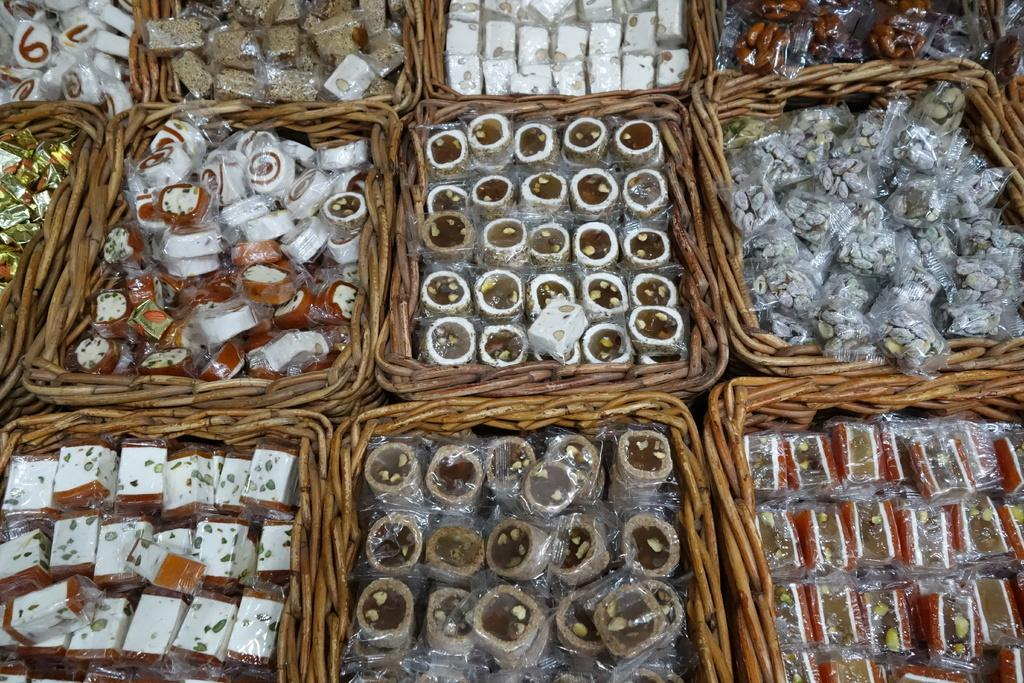What type of items can be seen in the image? There are sweets in the image. How are the sweets arranged or organized? The sweets are placed in baskets. What type of apparel is being worn by the children in the image? There are no children or apparel present in the image; it only features sweets placed in baskets. 